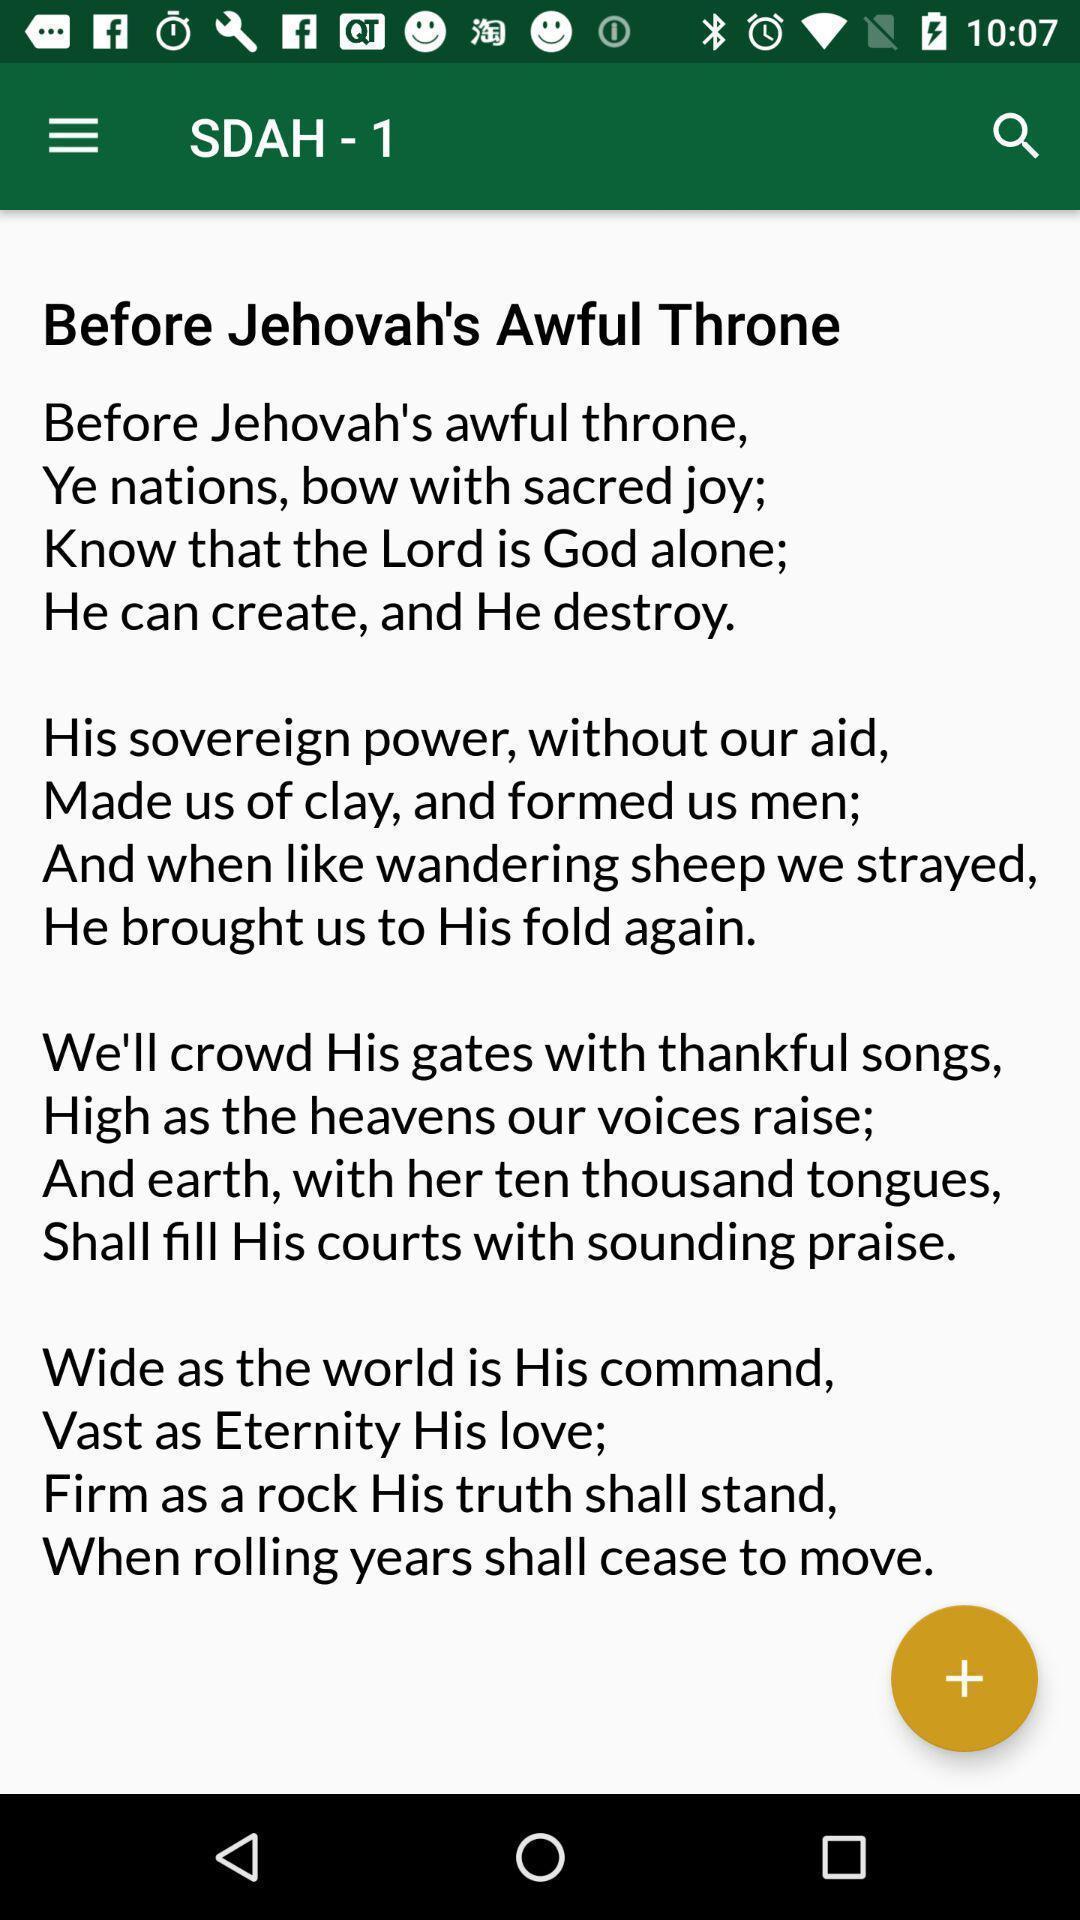Summarize the main components in this picture. Page showing the article information. 